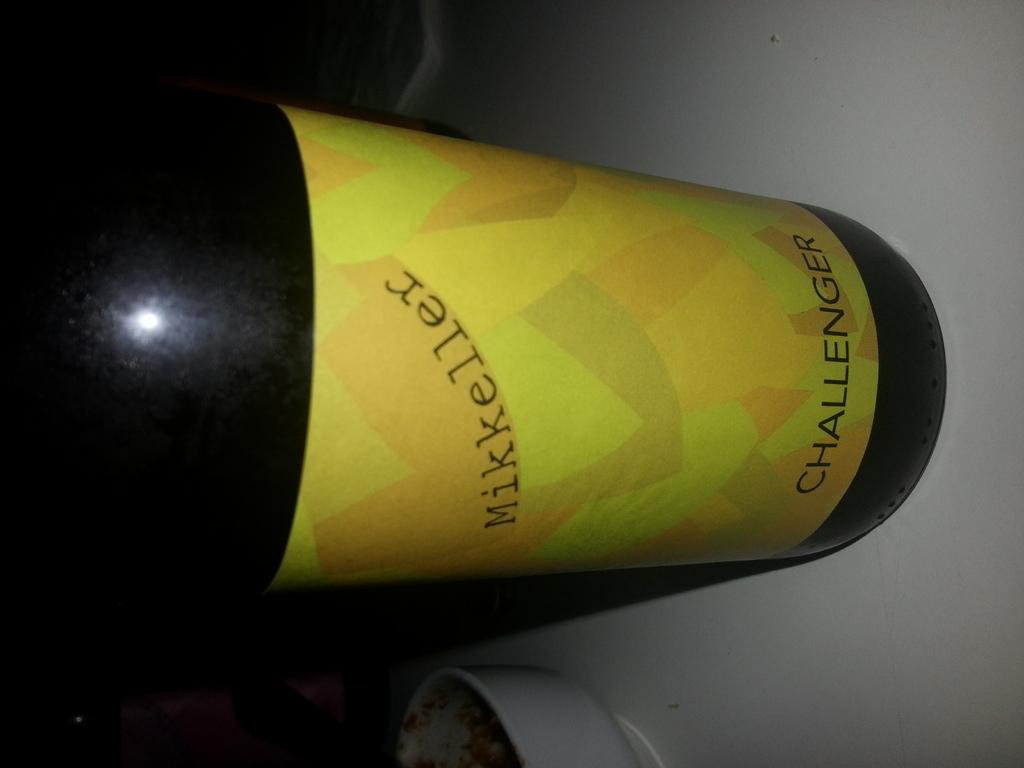What is the name of this drink?
Offer a terse response. Challenger. What company makes the drink?
Provide a short and direct response. Mikkeller. 